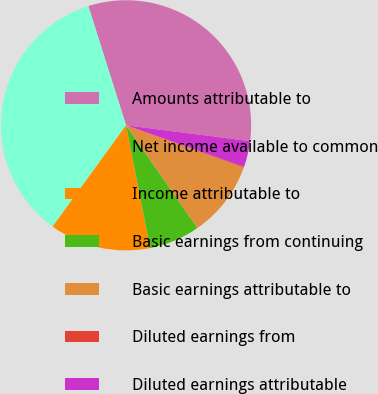<chart> <loc_0><loc_0><loc_500><loc_500><pie_chart><fcel>Amounts attributable to<fcel>Net income available to common<fcel>Income attributable to<fcel>Basic earnings from continuing<fcel>Basic earnings attributable to<fcel>Diluted earnings from<fcel>Diluted earnings attributable<nl><fcel>31.9%<fcel>35.14%<fcel>13.07%<fcel>6.59%<fcel>9.83%<fcel>0.12%<fcel>3.36%<nl></chart> 